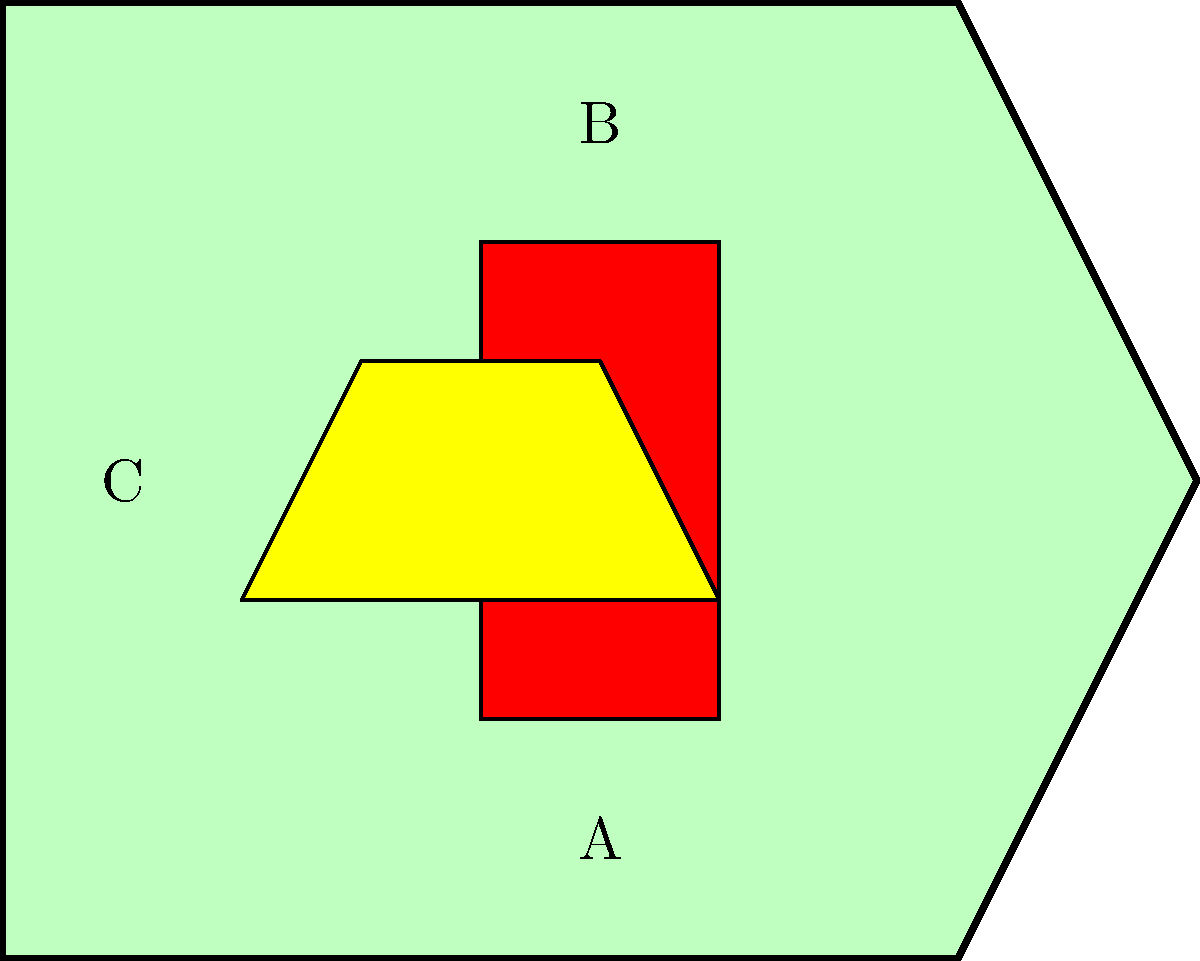In the given heraldic shield representing a noble family from Luxemburg, which element is most likely associated with the House of Luxembourg? To answer this question, we need to analyze the elements present in the heraldic shield:

1. The shield shape: A traditional shape used in heraldry, not specific to Luxemburg.

2. Element A: A yellow (or gold) figure in the center, resembling a stylized lion. This is significant because:
   - The lion is a common symbol in European heraldry.
   - A gold lion on a blue field is part of the coat of arms of Luxembourg.

3. Element B: A red cross in the upper part of the shield. While important in heraldry, it's not specifically associated with Luxemburg.

4. Element C: The green background of the shield. Green is not a primary color in Luxembourg's heraldry.

Given these elements, the lion (Element A) is most likely associated with the House of Luxembourg. The House of Luxembourg historically used a lion in their coat of arms, which later became part of the national symbol of Luxembourg. The red lion rampant on a striped silver and blue field has been a symbol of Luxembourg since the late 13th century, introduced by Henry V of Luxembourg.

While the colors in this simplified representation differ from the official Luxembourg coat of arms, the presence of a lion figure is the strongest connection to Luxembourg's noble heraldry.
Answer: The lion (Element A) 